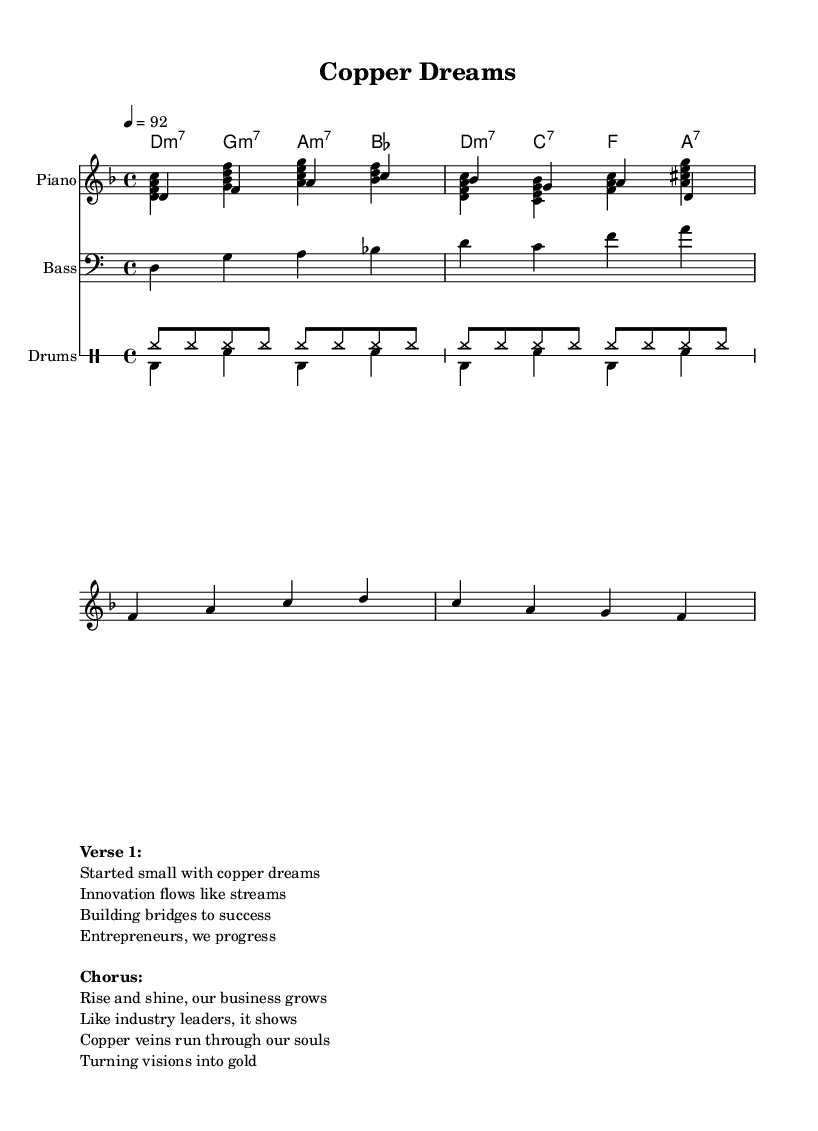What is the key signature of this music? The key signature is D minor, indicated by the notation in the global block of the LilyPond code. D minor has one flat (B flat).
Answer: D minor What is the time signature of this music? The time signature is 4/4, as specified in the global block of the LilyPond code. This indicates four beats per measure.
Answer: 4/4 What is the tempo marking of this piece? The tempo marking is 92 beats per minute, which is stated in the global section of the code. It dictates the speed of the music.
Answer: 92 How many bars are in the melody section? The melody section consists of four measures (or bars) based on the grouping of notes defined in the melody variable. Each group separated by a vertical line represents a bar.
Answer: 4 What includes the main themes of the lyrics? The main themes of the lyrics revolve around business growth, innovation, and entrepreneurial spirit, as reflected in the verses and chorus. They express the journey of small beginnings to significant achievements.
Answer: Business growth and innovation How many different instruments are utilized in the score? There are three different instruments utilized: Piano, Bass, and Drums, as indicated in the score block with respective instrument names.
Answer: 3 What is the main chord progression in this music? The main chord progression alternates between D minor 7, G minor 7, A minor 7, and B flat in the chordNames section. This progression supports the soulful character of the piece.
Answer: D minor 7, G minor 7, A minor 7, B flat 